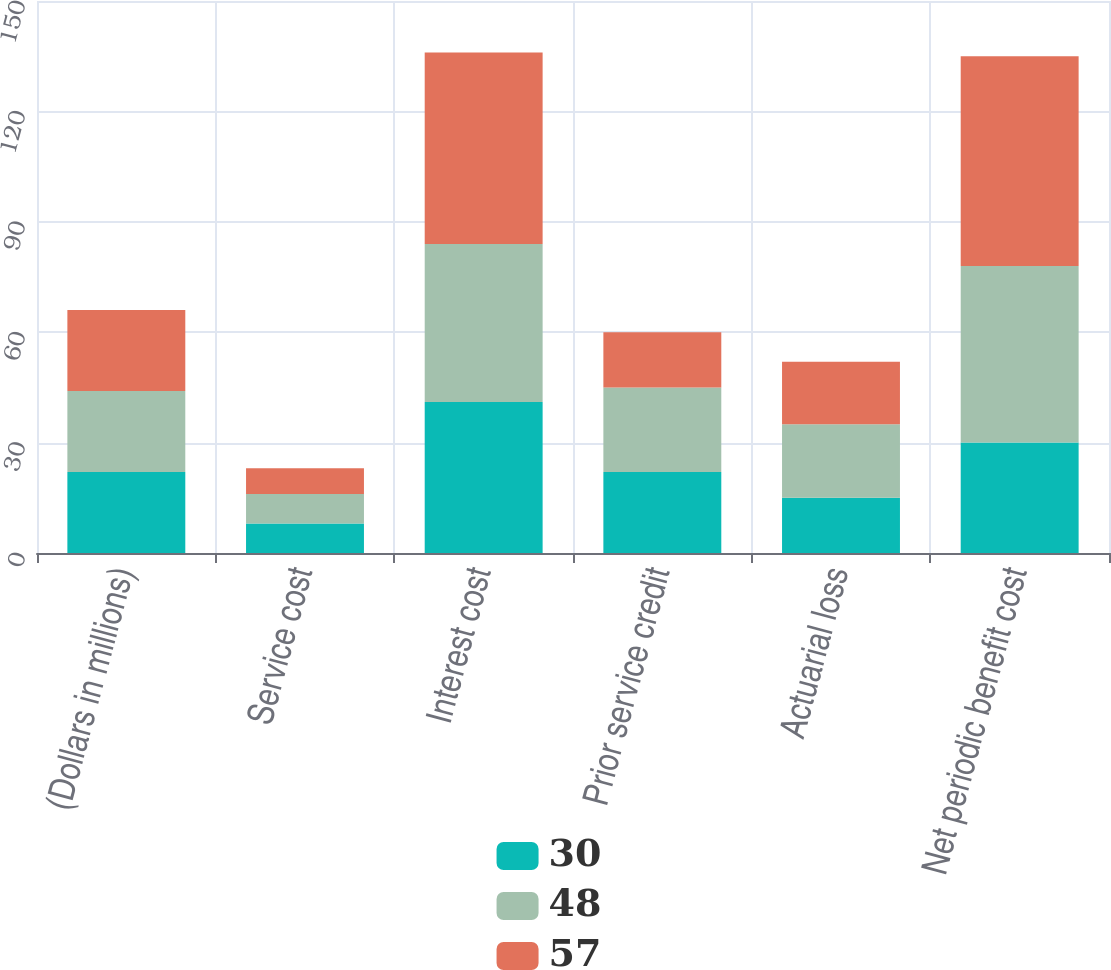<chart> <loc_0><loc_0><loc_500><loc_500><stacked_bar_chart><ecel><fcel>(Dollars in millions)<fcel>Service cost<fcel>Interest cost<fcel>Prior service credit<fcel>Actuarial loss<fcel>Net periodic benefit cost<nl><fcel>30<fcel>22<fcel>8<fcel>41<fcel>22<fcel>15<fcel>30<nl><fcel>48<fcel>22<fcel>8<fcel>43<fcel>23<fcel>20<fcel>48<nl><fcel>57<fcel>22<fcel>7<fcel>52<fcel>15<fcel>17<fcel>57<nl></chart> 